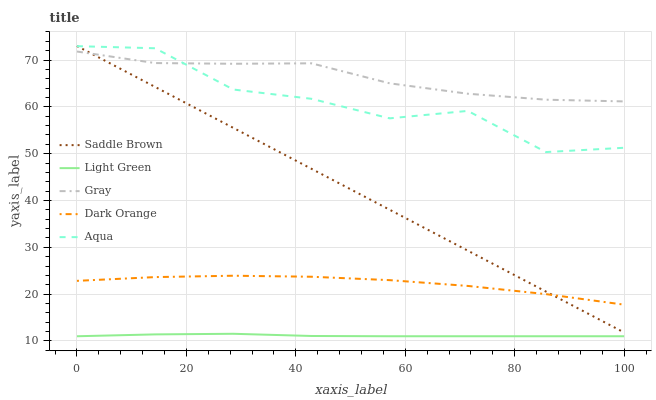Does Aqua have the minimum area under the curve?
Answer yes or no. No. Does Aqua have the maximum area under the curve?
Answer yes or no. No. Is Aqua the smoothest?
Answer yes or no. No. Is Saddle Brown the roughest?
Answer yes or no. No. Does Aqua have the lowest value?
Answer yes or no. No. Does Aqua have the highest value?
Answer yes or no. No. Is Dark Orange less than Aqua?
Answer yes or no. Yes. Is Dark Orange greater than Light Green?
Answer yes or no. Yes. Does Dark Orange intersect Aqua?
Answer yes or no. No. 